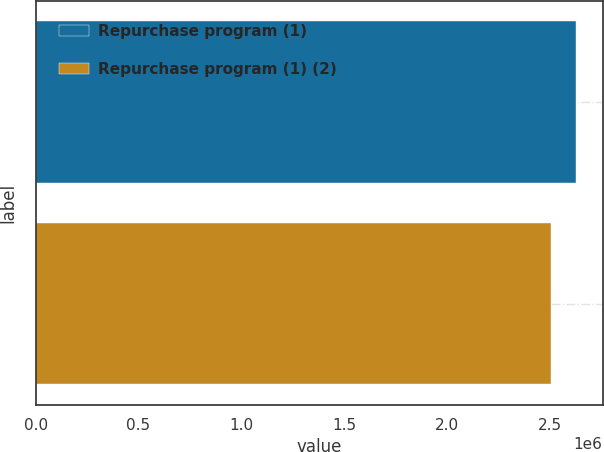Convert chart. <chart><loc_0><loc_0><loc_500><loc_500><bar_chart><fcel>Repurchase program (1)<fcel>Repurchase program (1) (2)<nl><fcel>2.6248e+06<fcel>2.50407e+06<nl></chart> 